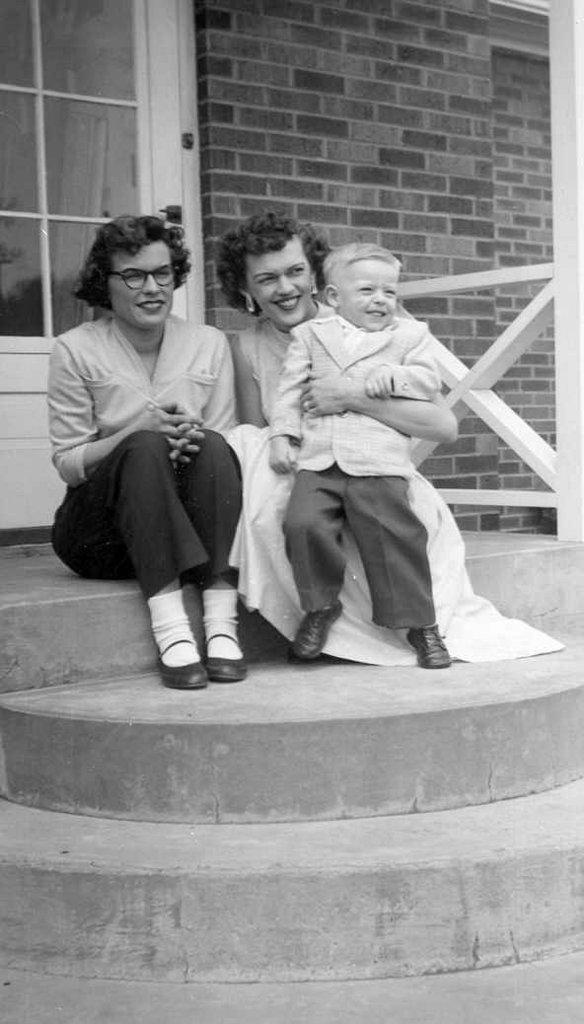What are the people in the image doing? The people in the image are sitting on a stair. Can you describe the interaction between the people? One person is holding a kid. What structures are visible in the image? There is a door and a wall visible in the image. What type of potato is being used as a seat by the people in the image? There is no potato present in the image; the people are sitting on a stair. Can you read the note that is being passed between the people in the image? There is no note present in the image; the people are simply sitting on the stair. 